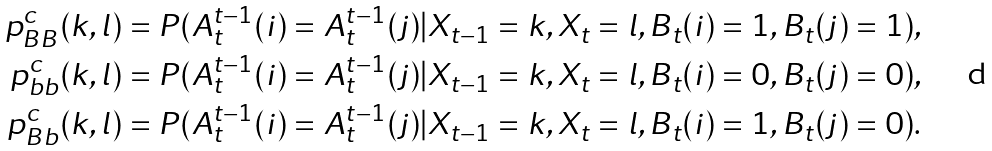Convert formula to latex. <formula><loc_0><loc_0><loc_500><loc_500>p _ { B B } ^ { c } ( k , l ) & = P ( A _ { t } ^ { t - 1 } ( i ) = A _ { t } ^ { t - 1 } ( j ) | X _ { t - 1 } = k , X _ { t } = l , B _ { t } ( i ) = 1 , B _ { t } ( j ) = 1 ) , \\ p _ { b b } ^ { c } ( k , l ) & = P ( A _ { t } ^ { t - 1 } ( i ) = A _ { t } ^ { t - 1 } ( j ) | X _ { t - 1 } = k , X _ { t } = l , B _ { t } ( i ) = 0 , B _ { t } ( j ) = 0 ) , \\ p _ { B b } ^ { c } ( k , l ) & = P ( A _ { t } ^ { t - 1 } ( i ) = A _ { t } ^ { t - 1 } ( j ) | X _ { t - 1 } = k , X _ { t } = l , B _ { t } ( i ) = 1 , B _ { t } ( j ) = 0 ) .</formula> 